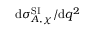<formula> <loc_0><loc_0><loc_500><loc_500>d \sigma _ { A , \chi } ^ { S I } / d q ^ { 2 }</formula> 